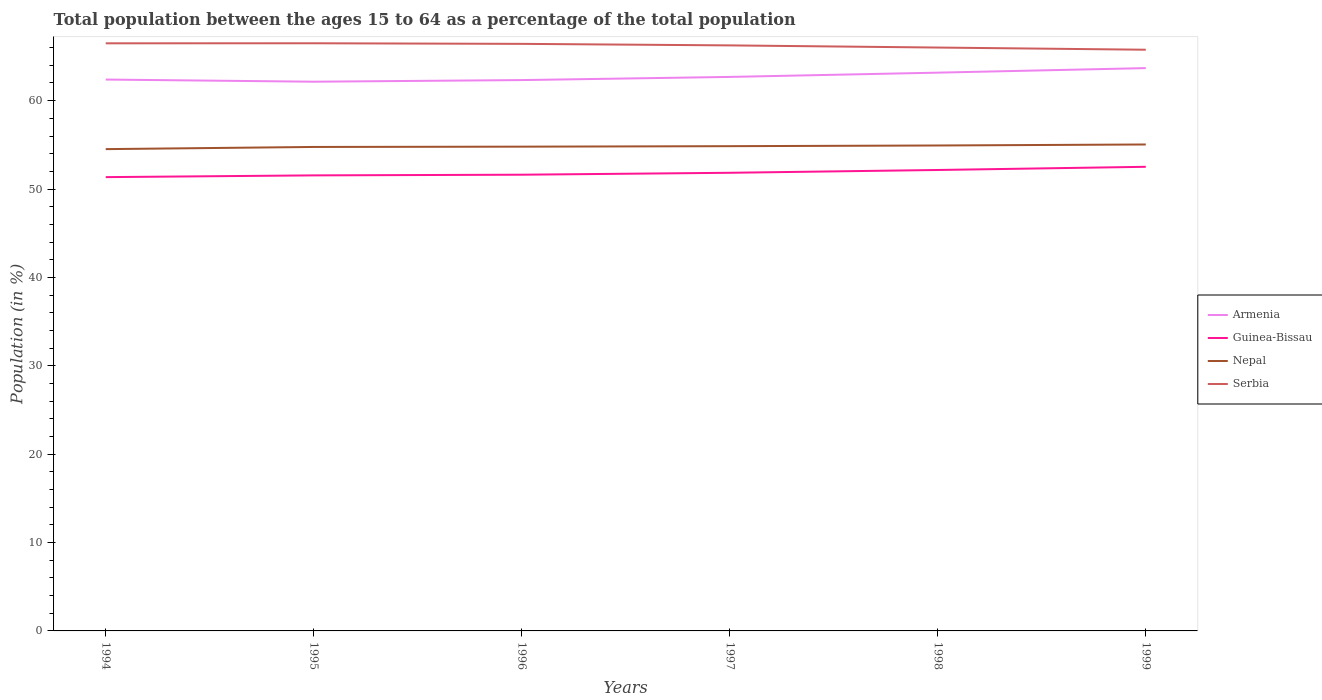Is the number of lines equal to the number of legend labels?
Your response must be concise. Yes. Across all years, what is the maximum percentage of the population ages 15 to 64 in Guinea-Bissau?
Make the answer very short. 51.35. What is the total percentage of the population ages 15 to 64 in Serbia in the graph?
Your answer should be compact. 0.73. What is the difference between the highest and the second highest percentage of the population ages 15 to 64 in Armenia?
Your response must be concise. 1.54. Is the percentage of the population ages 15 to 64 in Serbia strictly greater than the percentage of the population ages 15 to 64 in Guinea-Bissau over the years?
Your answer should be very brief. No. How many lines are there?
Your response must be concise. 4. Are the values on the major ticks of Y-axis written in scientific E-notation?
Provide a short and direct response. No. Does the graph contain any zero values?
Offer a very short reply. No. What is the title of the graph?
Ensure brevity in your answer.  Total population between the ages 15 to 64 as a percentage of the total population. Does "Albania" appear as one of the legend labels in the graph?
Your answer should be very brief. No. What is the label or title of the Y-axis?
Your response must be concise. Population (in %). What is the Population (in %) in Armenia in 1994?
Make the answer very short. 62.39. What is the Population (in %) of Guinea-Bissau in 1994?
Ensure brevity in your answer.  51.35. What is the Population (in %) of Nepal in 1994?
Make the answer very short. 54.52. What is the Population (in %) of Serbia in 1994?
Make the answer very short. 66.49. What is the Population (in %) of Armenia in 1995?
Offer a terse response. 62.14. What is the Population (in %) of Guinea-Bissau in 1995?
Provide a succinct answer. 51.54. What is the Population (in %) in Nepal in 1995?
Provide a short and direct response. 54.76. What is the Population (in %) in Serbia in 1995?
Make the answer very short. 66.49. What is the Population (in %) in Armenia in 1996?
Your answer should be compact. 62.33. What is the Population (in %) in Guinea-Bissau in 1996?
Your answer should be very brief. 51.62. What is the Population (in %) of Nepal in 1996?
Make the answer very short. 54.79. What is the Population (in %) of Serbia in 1996?
Your answer should be very brief. 66.43. What is the Population (in %) in Armenia in 1997?
Provide a short and direct response. 62.69. What is the Population (in %) of Guinea-Bissau in 1997?
Provide a succinct answer. 51.84. What is the Population (in %) of Nepal in 1997?
Give a very brief answer. 54.85. What is the Population (in %) in Serbia in 1997?
Your answer should be compact. 66.25. What is the Population (in %) in Armenia in 1998?
Give a very brief answer. 63.17. What is the Population (in %) of Guinea-Bissau in 1998?
Offer a terse response. 52.16. What is the Population (in %) in Nepal in 1998?
Your answer should be compact. 54.93. What is the Population (in %) of Serbia in 1998?
Provide a short and direct response. 66.01. What is the Population (in %) of Armenia in 1999?
Your answer should be very brief. 63.68. What is the Population (in %) of Guinea-Bissau in 1999?
Give a very brief answer. 52.52. What is the Population (in %) of Nepal in 1999?
Give a very brief answer. 55.04. What is the Population (in %) of Serbia in 1999?
Your response must be concise. 65.76. Across all years, what is the maximum Population (in %) of Armenia?
Give a very brief answer. 63.68. Across all years, what is the maximum Population (in %) of Guinea-Bissau?
Provide a succinct answer. 52.52. Across all years, what is the maximum Population (in %) of Nepal?
Keep it short and to the point. 55.04. Across all years, what is the maximum Population (in %) of Serbia?
Provide a succinct answer. 66.49. Across all years, what is the minimum Population (in %) in Armenia?
Ensure brevity in your answer.  62.14. Across all years, what is the minimum Population (in %) in Guinea-Bissau?
Ensure brevity in your answer.  51.35. Across all years, what is the minimum Population (in %) in Nepal?
Provide a succinct answer. 54.52. Across all years, what is the minimum Population (in %) of Serbia?
Offer a very short reply. 65.76. What is the total Population (in %) of Armenia in the graph?
Ensure brevity in your answer.  376.4. What is the total Population (in %) in Guinea-Bissau in the graph?
Make the answer very short. 311.03. What is the total Population (in %) of Nepal in the graph?
Offer a terse response. 328.89. What is the total Population (in %) in Serbia in the graph?
Make the answer very short. 397.43. What is the difference between the Population (in %) in Armenia in 1994 and that in 1995?
Keep it short and to the point. 0.24. What is the difference between the Population (in %) of Guinea-Bissau in 1994 and that in 1995?
Your answer should be compact. -0.2. What is the difference between the Population (in %) of Nepal in 1994 and that in 1995?
Offer a terse response. -0.25. What is the difference between the Population (in %) of Serbia in 1994 and that in 1995?
Keep it short and to the point. -0. What is the difference between the Population (in %) in Armenia in 1994 and that in 1996?
Offer a very short reply. 0.06. What is the difference between the Population (in %) of Guinea-Bissau in 1994 and that in 1996?
Provide a succinct answer. -0.27. What is the difference between the Population (in %) in Nepal in 1994 and that in 1996?
Your response must be concise. -0.28. What is the difference between the Population (in %) of Serbia in 1994 and that in 1996?
Give a very brief answer. 0.06. What is the difference between the Population (in %) in Armenia in 1994 and that in 1997?
Your answer should be compact. -0.3. What is the difference between the Population (in %) in Guinea-Bissau in 1994 and that in 1997?
Keep it short and to the point. -0.49. What is the difference between the Population (in %) in Nepal in 1994 and that in 1997?
Your response must be concise. -0.33. What is the difference between the Population (in %) in Serbia in 1994 and that in 1997?
Your answer should be very brief. 0.24. What is the difference between the Population (in %) of Armenia in 1994 and that in 1998?
Ensure brevity in your answer.  -0.78. What is the difference between the Population (in %) of Guinea-Bissau in 1994 and that in 1998?
Provide a succinct answer. -0.81. What is the difference between the Population (in %) of Nepal in 1994 and that in 1998?
Your response must be concise. -0.41. What is the difference between the Population (in %) in Serbia in 1994 and that in 1998?
Provide a short and direct response. 0.48. What is the difference between the Population (in %) in Armenia in 1994 and that in 1999?
Your answer should be compact. -1.29. What is the difference between the Population (in %) of Guinea-Bissau in 1994 and that in 1999?
Provide a short and direct response. -1.17. What is the difference between the Population (in %) of Nepal in 1994 and that in 1999?
Your response must be concise. -0.53. What is the difference between the Population (in %) of Serbia in 1994 and that in 1999?
Give a very brief answer. 0.73. What is the difference between the Population (in %) of Armenia in 1995 and that in 1996?
Make the answer very short. -0.18. What is the difference between the Population (in %) in Guinea-Bissau in 1995 and that in 1996?
Ensure brevity in your answer.  -0.08. What is the difference between the Population (in %) of Nepal in 1995 and that in 1996?
Your answer should be very brief. -0.03. What is the difference between the Population (in %) of Serbia in 1995 and that in 1996?
Offer a very short reply. 0.07. What is the difference between the Population (in %) of Armenia in 1995 and that in 1997?
Your response must be concise. -0.54. What is the difference between the Population (in %) in Guinea-Bissau in 1995 and that in 1997?
Offer a terse response. -0.29. What is the difference between the Population (in %) of Nepal in 1995 and that in 1997?
Provide a short and direct response. -0.09. What is the difference between the Population (in %) in Serbia in 1995 and that in 1997?
Offer a terse response. 0.24. What is the difference between the Population (in %) in Armenia in 1995 and that in 1998?
Keep it short and to the point. -1.02. What is the difference between the Population (in %) in Guinea-Bissau in 1995 and that in 1998?
Give a very brief answer. -0.61. What is the difference between the Population (in %) in Nepal in 1995 and that in 1998?
Offer a very short reply. -0.17. What is the difference between the Population (in %) in Serbia in 1995 and that in 1998?
Offer a terse response. 0.48. What is the difference between the Population (in %) in Armenia in 1995 and that in 1999?
Offer a very short reply. -1.54. What is the difference between the Population (in %) of Guinea-Bissau in 1995 and that in 1999?
Ensure brevity in your answer.  -0.97. What is the difference between the Population (in %) in Nepal in 1995 and that in 1999?
Your answer should be compact. -0.28. What is the difference between the Population (in %) of Serbia in 1995 and that in 1999?
Give a very brief answer. 0.73. What is the difference between the Population (in %) in Armenia in 1996 and that in 1997?
Give a very brief answer. -0.36. What is the difference between the Population (in %) of Guinea-Bissau in 1996 and that in 1997?
Keep it short and to the point. -0.22. What is the difference between the Population (in %) in Nepal in 1996 and that in 1997?
Make the answer very short. -0.05. What is the difference between the Population (in %) in Serbia in 1996 and that in 1997?
Provide a succinct answer. 0.17. What is the difference between the Population (in %) in Armenia in 1996 and that in 1998?
Provide a succinct answer. -0.84. What is the difference between the Population (in %) in Guinea-Bissau in 1996 and that in 1998?
Ensure brevity in your answer.  -0.54. What is the difference between the Population (in %) of Nepal in 1996 and that in 1998?
Provide a short and direct response. -0.13. What is the difference between the Population (in %) of Serbia in 1996 and that in 1998?
Offer a terse response. 0.42. What is the difference between the Population (in %) of Armenia in 1996 and that in 1999?
Your answer should be very brief. -1.35. What is the difference between the Population (in %) of Guinea-Bissau in 1996 and that in 1999?
Make the answer very short. -0.9. What is the difference between the Population (in %) in Nepal in 1996 and that in 1999?
Provide a short and direct response. -0.25. What is the difference between the Population (in %) in Serbia in 1996 and that in 1999?
Provide a succinct answer. 0.66. What is the difference between the Population (in %) in Armenia in 1997 and that in 1998?
Provide a short and direct response. -0.48. What is the difference between the Population (in %) in Guinea-Bissau in 1997 and that in 1998?
Offer a very short reply. -0.32. What is the difference between the Population (in %) of Nepal in 1997 and that in 1998?
Make the answer very short. -0.08. What is the difference between the Population (in %) of Serbia in 1997 and that in 1998?
Your answer should be compact. 0.24. What is the difference between the Population (in %) in Armenia in 1997 and that in 1999?
Your answer should be compact. -1. What is the difference between the Population (in %) of Guinea-Bissau in 1997 and that in 1999?
Your answer should be very brief. -0.68. What is the difference between the Population (in %) in Nepal in 1997 and that in 1999?
Your answer should be very brief. -0.19. What is the difference between the Population (in %) of Serbia in 1997 and that in 1999?
Make the answer very short. 0.49. What is the difference between the Population (in %) of Armenia in 1998 and that in 1999?
Provide a short and direct response. -0.51. What is the difference between the Population (in %) in Guinea-Bissau in 1998 and that in 1999?
Ensure brevity in your answer.  -0.36. What is the difference between the Population (in %) of Nepal in 1998 and that in 1999?
Ensure brevity in your answer.  -0.11. What is the difference between the Population (in %) of Serbia in 1998 and that in 1999?
Provide a succinct answer. 0.25. What is the difference between the Population (in %) in Armenia in 1994 and the Population (in %) in Guinea-Bissau in 1995?
Give a very brief answer. 10.84. What is the difference between the Population (in %) of Armenia in 1994 and the Population (in %) of Nepal in 1995?
Offer a very short reply. 7.63. What is the difference between the Population (in %) of Armenia in 1994 and the Population (in %) of Serbia in 1995?
Your answer should be compact. -4.11. What is the difference between the Population (in %) of Guinea-Bissau in 1994 and the Population (in %) of Nepal in 1995?
Ensure brevity in your answer.  -3.41. What is the difference between the Population (in %) in Guinea-Bissau in 1994 and the Population (in %) in Serbia in 1995?
Provide a succinct answer. -15.15. What is the difference between the Population (in %) of Nepal in 1994 and the Population (in %) of Serbia in 1995?
Offer a very short reply. -11.98. What is the difference between the Population (in %) of Armenia in 1994 and the Population (in %) of Guinea-Bissau in 1996?
Provide a short and direct response. 10.77. What is the difference between the Population (in %) in Armenia in 1994 and the Population (in %) in Nepal in 1996?
Provide a short and direct response. 7.59. What is the difference between the Population (in %) in Armenia in 1994 and the Population (in %) in Serbia in 1996?
Offer a very short reply. -4.04. What is the difference between the Population (in %) of Guinea-Bissau in 1994 and the Population (in %) of Nepal in 1996?
Ensure brevity in your answer.  -3.45. What is the difference between the Population (in %) in Guinea-Bissau in 1994 and the Population (in %) in Serbia in 1996?
Ensure brevity in your answer.  -15.08. What is the difference between the Population (in %) in Nepal in 1994 and the Population (in %) in Serbia in 1996?
Make the answer very short. -11.91. What is the difference between the Population (in %) in Armenia in 1994 and the Population (in %) in Guinea-Bissau in 1997?
Ensure brevity in your answer.  10.55. What is the difference between the Population (in %) in Armenia in 1994 and the Population (in %) in Nepal in 1997?
Your answer should be compact. 7.54. What is the difference between the Population (in %) in Armenia in 1994 and the Population (in %) in Serbia in 1997?
Keep it short and to the point. -3.87. What is the difference between the Population (in %) in Guinea-Bissau in 1994 and the Population (in %) in Nepal in 1997?
Make the answer very short. -3.5. What is the difference between the Population (in %) in Guinea-Bissau in 1994 and the Population (in %) in Serbia in 1997?
Ensure brevity in your answer.  -14.91. What is the difference between the Population (in %) in Nepal in 1994 and the Population (in %) in Serbia in 1997?
Keep it short and to the point. -11.74. What is the difference between the Population (in %) of Armenia in 1994 and the Population (in %) of Guinea-Bissau in 1998?
Offer a terse response. 10.23. What is the difference between the Population (in %) of Armenia in 1994 and the Population (in %) of Nepal in 1998?
Give a very brief answer. 7.46. What is the difference between the Population (in %) of Armenia in 1994 and the Population (in %) of Serbia in 1998?
Offer a very short reply. -3.62. What is the difference between the Population (in %) of Guinea-Bissau in 1994 and the Population (in %) of Nepal in 1998?
Your answer should be very brief. -3.58. What is the difference between the Population (in %) in Guinea-Bissau in 1994 and the Population (in %) in Serbia in 1998?
Offer a very short reply. -14.66. What is the difference between the Population (in %) in Nepal in 1994 and the Population (in %) in Serbia in 1998?
Offer a terse response. -11.49. What is the difference between the Population (in %) in Armenia in 1994 and the Population (in %) in Guinea-Bissau in 1999?
Ensure brevity in your answer.  9.87. What is the difference between the Population (in %) of Armenia in 1994 and the Population (in %) of Nepal in 1999?
Give a very brief answer. 7.35. What is the difference between the Population (in %) in Armenia in 1994 and the Population (in %) in Serbia in 1999?
Keep it short and to the point. -3.38. What is the difference between the Population (in %) in Guinea-Bissau in 1994 and the Population (in %) in Nepal in 1999?
Your response must be concise. -3.69. What is the difference between the Population (in %) in Guinea-Bissau in 1994 and the Population (in %) in Serbia in 1999?
Offer a very short reply. -14.42. What is the difference between the Population (in %) of Nepal in 1994 and the Population (in %) of Serbia in 1999?
Your answer should be compact. -11.25. What is the difference between the Population (in %) of Armenia in 1995 and the Population (in %) of Guinea-Bissau in 1996?
Offer a terse response. 10.52. What is the difference between the Population (in %) of Armenia in 1995 and the Population (in %) of Nepal in 1996?
Provide a short and direct response. 7.35. What is the difference between the Population (in %) of Armenia in 1995 and the Population (in %) of Serbia in 1996?
Offer a very short reply. -4.28. What is the difference between the Population (in %) in Guinea-Bissau in 1995 and the Population (in %) in Nepal in 1996?
Your answer should be very brief. -3.25. What is the difference between the Population (in %) in Guinea-Bissau in 1995 and the Population (in %) in Serbia in 1996?
Offer a very short reply. -14.88. What is the difference between the Population (in %) in Nepal in 1995 and the Population (in %) in Serbia in 1996?
Offer a terse response. -11.67. What is the difference between the Population (in %) in Armenia in 1995 and the Population (in %) in Guinea-Bissau in 1997?
Keep it short and to the point. 10.31. What is the difference between the Population (in %) of Armenia in 1995 and the Population (in %) of Nepal in 1997?
Ensure brevity in your answer.  7.3. What is the difference between the Population (in %) of Armenia in 1995 and the Population (in %) of Serbia in 1997?
Give a very brief answer. -4.11. What is the difference between the Population (in %) in Guinea-Bissau in 1995 and the Population (in %) in Nepal in 1997?
Give a very brief answer. -3.3. What is the difference between the Population (in %) in Guinea-Bissau in 1995 and the Population (in %) in Serbia in 1997?
Provide a short and direct response. -14.71. What is the difference between the Population (in %) of Nepal in 1995 and the Population (in %) of Serbia in 1997?
Give a very brief answer. -11.49. What is the difference between the Population (in %) of Armenia in 1995 and the Population (in %) of Guinea-Bissau in 1998?
Your answer should be very brief. 9.99. What is the difference between the Population (in %) of Armenia in 1995 and the Population (in %) of Nepal in 1998?
Your answer should be very brief. 7.22. What is the difference between the Population (in %) of Armenia in 1995 and the Population (in %) of Serbia in 1998?
Your answer should be compact. -3.86. What is the difference between the Population (in %) in Guinea-Bissau in 1995 and the Population (in %) in Nepal in 1998?
Offer a terse response. -3.38. What is the difference between the Population (in %) in Guinea-Bissau in 1995 and the Population (in %) in Serbia in 1998?
Your answer should be very brief. -14.46. What is the difference between the Population (in %) in Nepal in 1995 and the Population (in %) in Serbia in 1998?
Your response must be concise. -11.25. What is the difference between the Population (in %) in Armenia in 1995 and the Population (in %) in Guinea-Bissau in 1999?
Give a very brief answer. 9.63. What is the difference between the Population (in %) in Armenia in 1995 and the Population (in %) in Nepal in 1999?
Your response must be concise. 7.1. What is the difference between the Population (in %) of Armenia in 1995 and the Population (in %) of Serbia in 1999?
Ensure brevity in your answer.  -3.62. What is the difference between the Population (in %) in Guinea-Bissau in 1995 and the Population (in %) in Nepal in 1999?
Keep it short and to the point. -3.5. What is the difference between the Population (in %) in Guinea-Bissau in 1995 and the Population (in %) in Serbia in 1999?
Offer a terse response. -14.22. What is the difference between the Population (in %) in Nepal in 1995 and the Population (in %) in Serbia in 1999?
Make the answer very short. -11. What is the difference between the Population (in %) in Armenia in 1996 and the Population (in %) in Guinea-Bissau in 1997?
Offer a terse response. 10.49. What is the difference between the Population (in %) of Armenia in 1996 and the Population (in %) of Nepal in 1997?
Give a very brief answer. 7.48. What is the difference between the Population (in %) of Armenia in 1996 and the Population (in %) of Serbia in 1997?
Your response must be concise. -3.92. What is the difference between the Population (in %) in Guinea-Bissau in 1996 and the Population (in %) in Nepal in 1997?
Ensure brevity in your answer.  -3.23. What is the difference between the Population (in %) of Guinea-Bissau in 1996 and the Population (in %) of Serbia in 1997?
Your response must be concise. -14.63. What is the difference between the Population (in %) in Nepal in 1996 and the Population (in %) in Serbia in 1997?
Your answer should be very brief. -11.46. What is the difference between the Population (in %) in Armenia in 1996 and the Population (in %) in Guinea-Bissau in 1998?
Provide a succinct answer. 10.17. What is the difference between the Population (in %) in Armenia in 1996 and the Population (in %) in Nepal in 1998?
Keep it short and to the point. 7.4. What is the difference between the Population (in %) of Armenia in 1996 and the Population (in %) of Serbia in 1998?
Ensure brevity in your answer.  -3.68. What is the difference between the Population (in %) in Guinea-Bissau in 1996 and the Population (in %) in Nepal in 1998?
Keep it short and to the point. -3.31. What is the difference between the Population (in %) in Guinea-Bissau in 1996 and the Population (in %) in Serbia in 1998?
Your answer should be compact. -14.39. What is the difference between the Population (in %) in Nepal in 1996 and the Population (in %) in Serbia in 1998?
Your answer should be compact. -11.21. What is the difference between the Population (in %) in Armenia in 1996 and the Population (in %) in Guinea-Bissau in 1999?
Offer a terse response. 9.81. What is the difference between the Population (in %) in Armenia in 1996 and the Population (in %) in Nepal in 1999?
Ensure brevity in your answer.  7.29. What is the difference between the Population (in %) in Armenia in 1996 and the Population (in %) in Serbia in 1999?
Offer a very short reply. -3.43. What is the difference between the Population (in %) of Guinea-Bissau in 1996 and the Population (in %) of Nepal in 1999?
Keep it short and to the point. -3.42. What is the difference between the Population (in %) in Guinea-Bissau in 1996 and the Population (in %) in Serbia in 1999?
Your answer should be very brief. -14.14. What is the difference between the Population (in %) of Nepal in 1996 and the Population (in %) of Serbia in 1999?
Keep it short and to the point. -10.97. What is the difference between the Population (in %) in Armenia in 1997 and the Population (in %) in Guinea-Bissau in 1998?
Offer a very short reply. 10.53. What is the difference between the Population (in %) of Armenia in 1997 and the Population (in %) of Nepal in 1998?
Make the answer very short. 7.76. What is the difference between the Population (in %) of Armenia in 1997 and the Population (in %) of Serbia in 1998?
Offer a terse response. -3.32. What is the difference between the Population (in %) in Guinea-Bissau in 1997 and the Population (in %) in Nepal in 1998?
Your answer should be very brief. -3.09. What is the difference between the Population (in %) in Guinea-Bissau in 1997 and the Population (in %) in Serbia in 1998?
Provide a succinct answer. -14.17. What is the difference between the Population (in %) in Nepal in 1997 and the Population (in %) in Serbia in 1998?
Make the answer very short. -11.16. What is the difference between the Population (in %) of Armenia in 1997 and the Population (in %) of Guinea-Bissau in 1999?
Offer a very short reply. 10.17. What is the difference between the Population (in %) in Armenia in 1997 and the Population (in %) in Nepal in 1999?
Keep it short and to the point. 7.64. What is the difference between the Population (in %) of Armenia in 1997 and the Population (in %) of Serbia in 1999?
Offer a very short reply. -3.08. What is the difference between the Population (in %) of Guinea-Bissau in 1997 and the Population (in %) of Nepal in 1999?
Provide a succinct answer. -3.2. What is the difference between the Population (in %) of Guinea-Bissau in 1997 and the Population (in %) of Serbia in 1999?
Give a very brief answer. -13.92. What is the difference between the Population (in %) in Nepal in 1997 and the Population (in %) in Serbia in 1999?
Provide a short and direct response. -10.91. What is the difference between the Population (in %) of Armenia in 1998 and the Population (in %) of Guinea-Bissau in 1999?
Your response must be concise. 10.65. What is the difference between the Population (in %) in Armenia in 1998 and the Population (in %) in Nepal in 1999?
Ensure brevity in your answer.  8.13. What is the difference between the Population (in %) in Armenia in 1998 and the Population (in %) in Serbia in 1999?
Make the answer very short. -2.59. What is the difference between the Population (in %) of Guinea-Bissau in 1998 and the Population (in %) of Nepal in 1999?
Give a very brief answer. -2.89. What is the difference between the Population (in %) in Guinea-Bissau in 1998 and the Population (in %) in Serbia in 1999?
Provide a short and direct response. -13.61. What is the difference between the Population (in %) in Nepal in 1998 and the Population (in %) in Serbia in 1999?
Provide a short and direct response. -10.84. What is the average Population (in %) of Armenia per year?
Offer a terse response. 62.73. What is the average Population (in %) of Guinea-Bissau per year?
Your answer should be compact. 51.84. What is the average Population (in %) of Nepal per year?
Provide a short and direct response. 54.81. What is the average Population (in %) in Serbia per year?
Provide a succinct answer. 66.24. In the year 1994, what is the difference between the Population (in %) of Armenia and Population (in %) of Guinea-Bissau?
Offer a very short reply. 11.04. In the year 1994, what is the difference between the Population (in %) of Armenia and Population (in %) of Nepal?
Ensure brevity in your answer.  7.87. In the year 1994, what is the difference between the Population (in %) of Armenia and Population (in %) of Serbia?
Provide a succinct answer. -4.1. In the year 1994, what is the difference between the Population (in %) in Guinea-Bissau and Population (in %) in Nepal?
Your answer should be very brief. -3.17. In the year 1994, what is the difference between the Population (in %) of Guinea-Bissau and Population (in %) of Serbia?
Offer a very short reply. -15.14. In the year 1994, what is the difference between the Population (in %) of Nepal and Population (in %) of Serbia?
Keep it short and to the point. -11.97. In the year 1995, what is the difference between the Population (in %) of Armenia and Population (in %) of Guinea-Bissau?
Your answer should be compact. 10.6. In the year 1995, what is the difference between the Population (in %) in Armenia and Population (in %) in Nepal?
Provide a succinct answer. 7.38. In the year 1995, what is the difference between the Population (in %) of Armenia and Population (in %) of Serbia?
Provide a short and direct response. -4.35. In the year 1995, what is the difference between the Population (in %) in Guinea-Bissau and Population (in %) in Nepal?
Your response must be concise. -3.22. In the year 1995, what is the difference between the Population (in %) in Guinea-Bissau and Population (in %) in Serbia?
Ensure brevity in your answer.  -14.95. In the year 1995, what is the difference between the Population (in %) in Nepal and Population (in %) in Serbia?
Provide a short and direct response. -11.73. In the year 1996, what is the difference between the Population (in %) in Armenia and Population (in %) in Guinea-Bissau?
Make the answer very short. 10.71. In the year 1996, what is the difference between the Population (in %) in Armenia and Population (in %) in Nepal?
Ensure brevity in your answer.  7.53. In the year 1996, what is the difference between the Population (in %) in Armenia and Population (in %) in Serbia?
Keep it short and to the point. -4.1. In the year 1996, what is the difference between the Population (in %) in Guinea-Bissau and Population (in %) in Nepal?
Your answer should be very brief. -3.17. In the year 1996, what is the difference between the Population (in %) of Guinea-Bissau and Population (in %) of Serbia?
Keep it short and to the point. -14.81. In the year 1996, what is the difference between the Population (in %) in Nepal and Population (in %) in Serbia?
Ensure brevity in your answer.  -11.63. In the year 1997, what is the difference between the Population (in %) in Armenia and Population (in %) in Guinea-Bissau?
Make the answer very short. 10.85. In the year 1997, what is the difference between the Population (in %) of Armenia and Population (in %) of Nepal?
Offer a terse response. 7.84. In the year 1997, what is the difference between the Population (in %) in Armenia and Population (in %) in Serbia?
Your answer should be compact. -3.57. In the year 1997, what is the difference between the Population (in %) in Guinea-Bissau and Population (in %) in Nepal?
Your response must be concise. -3.01. In the year 1997, what is the difference between the Population (in %) in Guinea-Bissau and Population (in %) in Serbia?
Offer a terse response. -14.41. In the year 1997, what is the difference between the Population (in %) of Nepal and Population (in %) of Serbia?
Your answer should be compact. -11.4. In the year 1998, what is the difference between the Population (in %) in Armenia and Population (in %) in Guinea-Bissau?
Give a very brief answer. 11.01. In the year 1998, what is the difference between the Population (in %) of Armenia and Population (in %) of Nepal?
Your response must be concise. 8.24. In the year 1998, what is the difference between the Population (in %) in Armenia and Population (in %) in Serbia?
Make the answer very short. -2.84. In the year 1998, what is the difference between the Population (in %) of Guinea-Bissau and Population (in %) of Nepal?
Ensure brevity in your answer.  -2.77. In the year 1998, what is the difference between the Population (in %) in Guinea-Bissau and Population (in %) in Serbia?
Your answer should be very brief. -13.85. In the year 1998, what is the difference between the Population (in %) of Nepal and Population (in %) of Serbia?
Provide a short and direct response. -11.08. In the year 1999, what is the difference between the Population (in %) of Armenia and Population (in %) of Guinea-Bissau?
Your response must be concise. 11.17. In the year 1999, what is the difference between the Population (in %) of Armenia and Population (in %) of Nepal?
Your answer should be compact. 8.64. In the year 1999, what is the difference between the Population (in %) of Armenia and Population (in %) of Serbia?
Provide a short and direct response. -2.08. In the year 1999, what is the difference between the Population (in %) of Guinea-Bissau and Population (in %) of Nepal?
Offer a very short reply. -2.53. In the year 1999, what is the difference between the Population (in %) in Guinea-Bissau and Population (in %) in Serbia?
Offer a terse response. -13.25. In the year 1999, what is the difference between the Population (in %) of Nepal and Population (in %) of Serbia?
Give a very brief answer. -10.72. What is the ratio of the Population (in %) of Guinea-Bissau in 1994 to that in 1995?
Your answer should be compact. 1. What is the ratio of the Population (in %) in Nepal in 1994 to that in 1995?
Keep it short and to the point. 1. What is the ratio of the Population (in %) in Armenia in 1994 to that in 1996?
Offer a terse response. 1. What is the ratio of the Population (in %) of Guinea-Bissau in 1994 to that in 1996?
Your answer should be compact. 0.99. What is the ratio of the Population (in %) of Serbia in 1994 to that in 1996?
Give a very brief answer. 1. What is the ratio of the Population (in %) in Armenia in 1994 to that in 1997?
Keep it short and to the point. 1. What is the ratio of the Population (in %) of Guinea-Bissau in 1994 to that in 1997?
Give a very brief answer. 0.99. What is the ratio of the Population (in %) in Nepal in 1994 to that in 1997?
Your response must be concise. 0.99. What is the ratio of the Population (in %) in Serbia in 1994 to that in 1997?
Your response must be concise. 1. What is the ratio of the Population (in %) of Armenia in 1994 to that in 1998?
Offer a terse response. 0.99. What is the ratio of the Population (in %) of Guinea-Bissau in 1994 to that in 1998?
Your answer should be compact. 0.98. What is the ratio of the Population (in %) in Nepal in 1994 to that in 1998?
Offer a terse response. 0.99. What is the ratio of the Population (in %) in Serbia in 1994 to that in 1998?
Your answer should be compact. 1.01. What is the ratio of the Population (in %) of Armenia in 1994 to that in 1999?
Make the answer very short. 0.98. What is the ratio of the Population (in %) in Guinea-Bissau in 1994 to that in 1999?
Ensure brevity in your answer.  0.98. What is the ratio of the Population (in %) of Nepal in 1994 to that in 1999?
Your answer should be compact. 0.99. What is the ratio of the Population (in %) of Nepal in 1995 to that in 1996?
Provide a short and direct response. 1. What is the ratio of the Population (in %) of Armenia in 1995 to that in 1997?
Your answer should be compact. 0.99. What is the ratio of the Population (in %) in Guinea-Bissau in 1995 to that in 1997?
Provide a succinct answer. 0.99. What is the ratio of the Population (in %) of Serbia in 1995 to that in 1997?
Your answer should be compact. 1. What is the ratio of the Population (in %) in Armenia in 1995 to that in 1998?
Offer a terse response. 0.98. What is the ratio of the Population (in %) of Guinea-Bissau in 1995 to that in 1998?
Provide a short and direct response. 0.99. What is the ratio of the Population (in %) in Serbia in 1995 to that in 1998?
Make the answer very short. 1.01. What is the ratio of the Population (in %) of Armenia in 1995 to that in 1999?
Your answer should be very brief. 0.98. What is the ratio of the Population (in %) of Guinea-Bissau in 1995 to that in 1999?
Offer a very short reply. 0.98. What is the ratio of the Population (in %) of Serbia in 1995 to that in 1999?
Offer a terse response. 1.01. What is the ratio of the Population (in %) in Guinea-Bissau in 1996 to that in 1997?
Offer a very short reply. 1. What is the ratio of the Population (in %) of Nepal in 1996 to that in 1997?
Provide a succinct answer. 1. What is the ratio of the Population (in %) in Serbia in 1996 to that in 1997?
Provide a short and direct response. 1. What is the ratio of the Population (in %) in Armenia in 1996 to that in 1998?
Ensure brevity in your answer.  0.99. What is the ratio of the Population (in %) in Nepal in 1996 to that in 1998?
Offer a terse response. 1. What is the ratio of the Population (in %) of Armenia in 1996 to that in 1999?
Give a very brief answer. 0.98. What is the ratio of the Population (in %) of Guinea-Bissau in 1996 to that in 1999?
Ensure brevity in your answer.  0.98. What is the ratio of the Population (in %) in Guinea-Bissau in 1997 to that in 1998?
Ensure brevity in your answer.  0.99. What is the ratio of the Population (in %) of Serbia in 1997 to that in 1998?
Give a very brief answer. 1. What is the ratio of the Population (in %) in Armenia in 1997 to that in 1999?
Your answer should be very brief. 0.98. What is the ratio of the Population (in %) of Guinea-Bissau in 1997 to that in 1999?
Make the answer very short. 0.99. What is the ratio of the Population (in %) of Serbia in 1997 to that in 1999?
Your answer should be compact. 1.01. What is the ratio of the Population (in %) in Guinea-Bissau in 1998 to that in 1999?
Your response must be concise. 0.99. What is the ratio of the Population (in %) in Nepal in 1998 to that in 1999?
Make the answer very short. 1. What is the ratio of the Population (in %) in Serbia in 1998 to that in 1999?
Keep it short and to the point. 1. What is the difference between the highest and the second highest Population (in %) in Armenia?
Make the answer very short. 0.51. What is the difference between the highest and the second highest Population (in %) of Guinea-Bissau?
Ensure brevity in your answer.  0.36. What is the difference between the highest and the second highest Population (in %) in Nepal?
Your response must be concise. 0.11. What is the difference between the highest and the second highest Population (in %) in Serbia?
Your answer should be compact. 0. What is the difference between the highest and the lowest Population (in %) in Armenia?
Provide a succinct answer. 1.54. What is the difference between the highest and the lowest Population (in %) of Guinea-Bissau?
Offer a very short reply. 1.17. What is the difference between the highest and the lowest Population (in %) of Nepal?
Offer a very short reply. 0.53. What is the difference between the highest and the lowest Population (in %) of Serbia?
Your response must be concise. 0.73. 